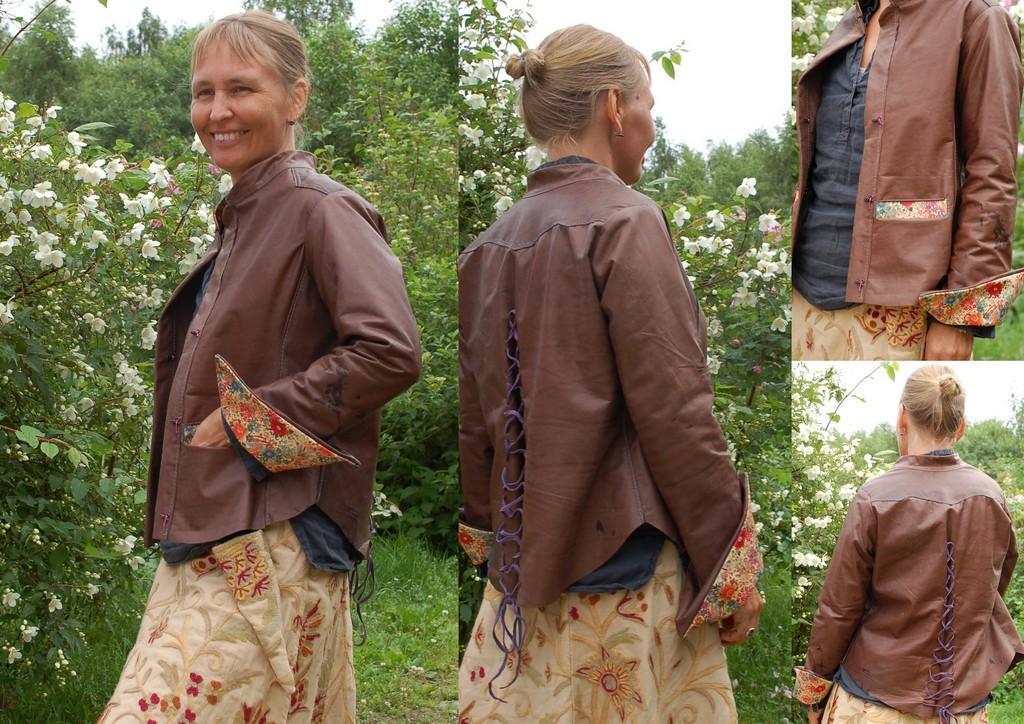Could you give a brief overview of what you see in this image? In this image I can see the collage picture and I can also see the person standing and the person is wearing brown, black and cream color dress. In the background I can see few flowers in white color, trees in green color and the sky is in white color. 